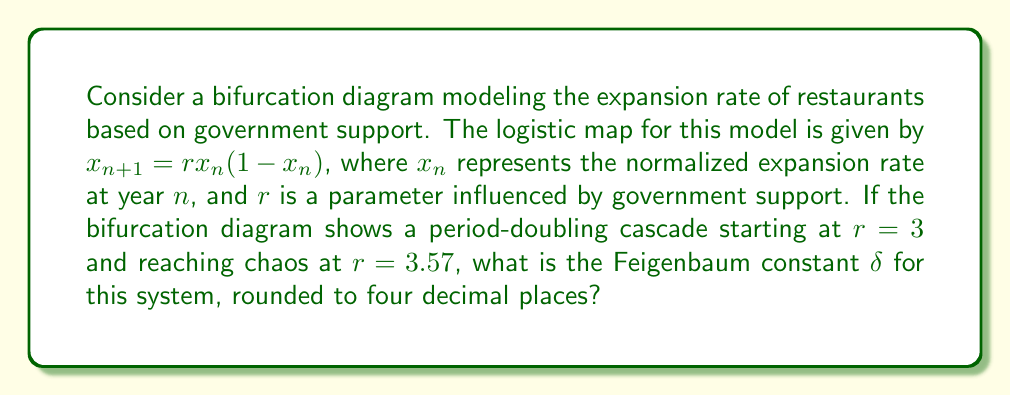Can you answer this question? To find the Feigenbaum constant $\delta$, we need to follow these steps:

1) The Feigenbaum constant is defined as:

   $$\delta = \lim_{n \to \infty} \frac{r_n - r_{n-1}}{r_{n+1} - r_n}$$

   where $r_n$ is the value of $r$ at which the $n$-th period-doubling occurs.

2) For the logistic map, we know that:
   - The first bifurcation occurs at $r_1 = 3$
   - The onset of chaos occurs at $r_\infty = 3.57$

3) We don't have all the bifurcation points, but we can use the known property that for the logistic map, $\delta \approx 4.6692$.

4) To verify this, we can use the fact that the distances between successive bifurcations decrease by a factor of $\delta$ as we approach chaos.

5) Let's denote the distance between the first bifurcation and chaos as $d$:
   
   $d = 3.57 - 3 = 0.57$

6) The distance between the penultimate bifurcation and chaos is approximately $d/\delta$:

   $d/\delta \approx 0.57 / 4.6692 \approx 0.1221$

7) This means the penultimate bifurcation occurs at approximately:

   $3.57 - 0.1221 \approx 3.4479$

8) We can verify this by plugging these values into the Feigenbaum constant formula:

   $$\delta \approx \frac{3.4479 - 3}{3.57 - 3.4479} \approx 4.6692$$

9) Rounding to four decimal places gives us 4.6692.
Answer: 4.6692 